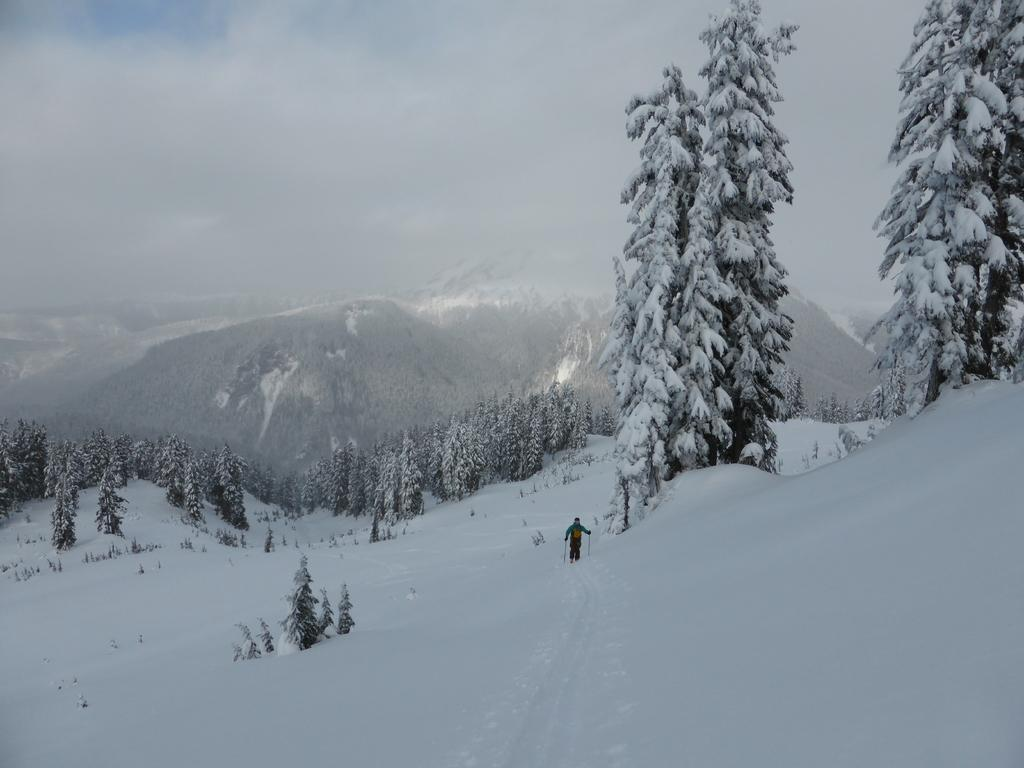What activity is the person in the image engaged in? The person is skiing in the image. What surface is the person skiing on? The person is skiing on snow. What can be seen in the background of the image? There are hills, trees, and the sky visible in the background of the image. What is the condition of the sky in the image? Clouds are present in the sky. What type of cast is the person wearing on their leg while skiing in the image? There is no cast visible on the person's leg in the image; they are skiing without any visible injuries or medical equipment. 